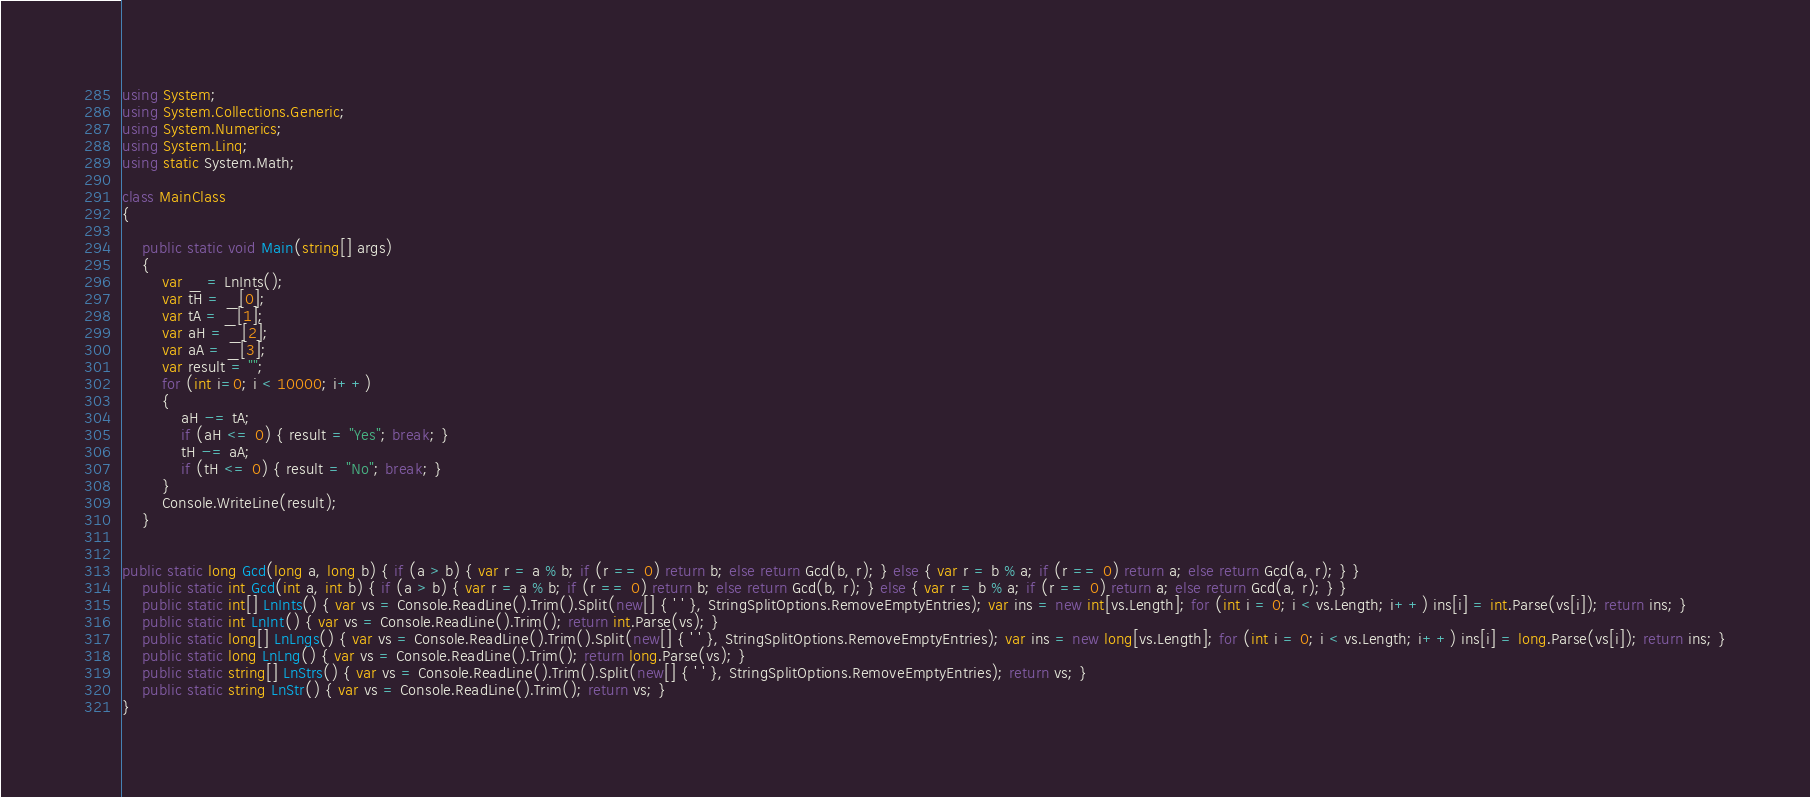Convert code to text. <code><loc_0><loc_0><loc_500><loc_500><_C#_>using System;
using System.Collections.Generic;
using System.Numerics;
using System.Linq;
using static System.Math;

class MainClass
{

    public static void Main(string[] args)
    {
        var _ = LnInts();
        var tH = _[0];
        var tA = _[1];
        var aH = _[2];
        var aA = _[3];
        var result = "";
        for (int i=0; i < 10000; i++)
        {
            aH -= tA;
            if (aH <= 0) { result = "Yes"; break; }
            tH -= aA;
            if (tH <= 0) { result = "No"; break; }
        }
        Console.WriteLine(result);
    }
   

public static long Gcd(long a, long b) { if (a > b) { var r = a % b; if (r == 0) return b; else return Gcd(b, r); } else { var r = b % a; if (r == 0) return a; else return Gcd(a, r); } }
    public static int Gcd(int a, int b) { if (a > b) { var r = a % b; if (r == 0) return b; else return Gcd(b, r); } else { var r = b % a; if (r == 0) return a; else return Gcd(a, r); } }
    public static int[] LnInts() { var vs = Console.ReadLine().Trim().Split(new[] { ' ' }, StringSplitOptions.RemoveEmptyEntries); var ins = new int[vs.Length]; for (int i = 0; i < vs.Length; i++) ins[i] = int.Parse(vs[i]); return ins; }
    public static int LnInt() { var vs = Console.ReadLine().Trim(); return int.Parse(vs); }
    public static long[] LnLngs() { var vs = Console.ReadLine().Trim().Split(new[] { ' ' }, StringSplitOptions.RemoveEmptyEntries); var ins = new long[vs.Length]; for (int i = 0; i < vs.Length; i++) ins[i] = long.Parse(vs[i]); return ins; }
    public static long LnLng() { var vs = Console.ReadLine().Trim(); return long.Parse(vs); }
    public static string[] LnStrs() { var vs = Console.ReadLine().Trim().Split(new[] { ' ' }, StringSplitOptions.RemoveEmptyEntries); return vs; }
    public static string LnStr() { var vs = Console.ReadLine().Trim(); return vs; }
}

</code> 